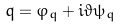<formula> <loc_0><loc_0><loc_500><loc_500>q = \varphi _ { q } + i \vartheta \psi _ { q }</formula> 